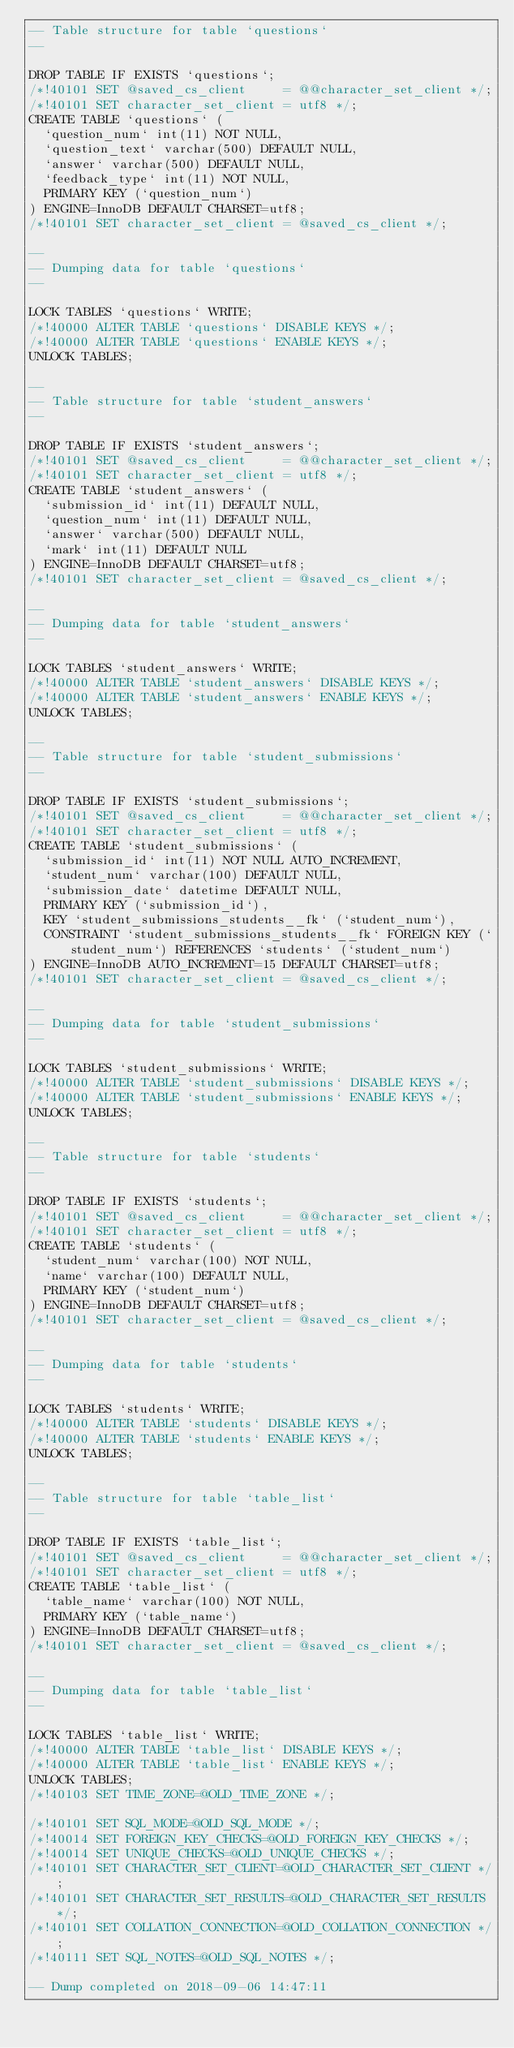Convert code to text. <code><loc_0><loc_0><loc_500><loc_500><_SQL_>-- Table structure for table `questions`
--

DROP TABLE IF EXISTS `questions`;
/*!40101 SET @saved_cs_client     = @@character_set_client */;
/*!40101 SET character_set_client = utf8 */;
CREATE TABLE `questions` (
  `question_num` int(11) NOT NULL,
  `question_text` varchar(500) DEFAULT NULL,
  `answer` varchar(500) DEFAULT NULL,
  `feedback_type` int(11) NOT NULL,
  PRIMARY KEY (`question_num`)
) ENGINE=InnoDB DEFAULT CHARSET=utf8;
/*!40101 SET character_set_client = @saved_cs_client */;

--
-- Dumping data for table `questions`
--

LOCK TABLES `questions` WRITE;
/*!40000 ALTER TABLE `questions` DISABLE KEYS */;
/*!40000 ALTER TABLE `questions` ENABLE KEYS */;
UNLOCK TABLES;

--
-- Table structure for table `student_answers`
--

DROP TABLE IF EXISTS `student_answers`;
/*!40101 SET @saved_cs_client     = @@character_set_client */;
/*!40101 SET character_set_client = utf8 */;
CREATE TABLE `student_answers` (
  `submission_id` int(11) DEFAULT NULL,
  `question_num` int(11) DEFAULT NULL,
  `answer` varchar(500) DEFAULT NULL,
  `mark` int(11) DEFAULT NULL
) ENGINE=InnoDB DEFAULT CHARSET=utf8;
/*!40101 SET character_set_client = @saved_cs_client */;

--
-- Dumping data for table `student_answers`
--

LOCK TABLES `student_answers` WRITE;
/*!40000 ALTER TABLE `student_answers` DISABLE KEYS */;
/*!40000 ALTER TABLE `student_answers` ENABLE KEYS */;
UNLOCK TABLES;

--
-- Table structure for table `student_submissions`
--

DROP TABLE IF EXISTS `student_submissions`;
/*!40101 SET @saved_cs_client     = @@character_set_client */;
/*!40101 SET character_set_client = utf8 */;
CREATE TABLE `student_submissions` (
  `submission_id` int(11) NOT NULL AUTO_INCREMENT,
  `student_num` varchar(100) DEFAULT NULL,
  `submission_date` datetime DEFAULT NULL,
  PRIMARY KEY (`submission_id`),
  KEY `student_submissions_students__fk` (`student_num`),
  CONSTRAINT `student_submissions_students__fk` FOREIGN KEY (`student_num`) REFERENCES `students` (`student_num`)
) ENGINE=InnoDB AUTO_INCREMENT=15 DEFAULT CHARSET=utf8;
/*!40101 SET character_set_client = @saved_cs_client */;

--
-- Dumping data for table `student_submissions`
--

LOCK TABLES `student_submissions` WRITE;
/*!40000 ALTER TABLE `student_submissions` DISABLE KEYS */;
/*!40000 ALTER TABLE `student_submissions` ENABLE KEYS */;
UNLOCK TABLES;

--
-- Table structure for table `students`
--

DROP TABLE IF EXISTS `students`;
/*!40101 SET @saved_cs_client     = @@character_set_client */;
/*!40101 SET character_set_client = utf8 */;
CREATE TABLE `students` (
  `student_num` varchar(100) NOT NULL,
  `name` varchar(100) DEFAULT NULL,
  PRIMARY KEY (`student_num`)
) ENGINE=InnoDB DEFAULT CHARSET=utf8;
/*!40101 SET character_set_client = @saved_cs_client */;

--
-- Dumping data for table `students`
--

LOCK TABLES `students` WRITE;
/*!40000 ALTER TABLE `students` DISABLE KEYS */;
/*!40000 ALTER TABLE `students` ENABLE KEYS */;
UNLOCK TABLES;

--
-- Table structure for table `table_list`
--

DROP TABLE IF EXISTS `table_list`;
/*!40101 SET @saved_cs_client     = @@character_set_client */;
/*!40101 SET character_set_client = utf8 */;
CREATE TABLE `table_list` (
  `table_name` varchar(100) NOT NULL,
  PRIMARY KEY (`table_name`)
) ENGINE=InnoDB DEFAULT CHARSET=utf8;
/*!40101 SET character_set_client = @saved_cs_client */;

--
-- Dumping data for table `table_list`
--

LOCK TABLES `table_list` WRITE;
/*!40000 ALTER TABLE `table_list` DISABLE KEYS */;
/*!40000 ALTER TABLE `table_list` ENABLE KEYS */;
UNLOCK TABLES;
/*!40103 SET TIME_ZONE=@OLD_TIME_ZONE */;

/*!40101 SET SQL_MODE=@OLD_SQL_MODE */;
/*!40014 SET FOREIGN_KEY_CHECKS=@OLD_FOREIGN_KEY_CHECKS */;
/*!40014 SET UNIQUE_CHECKS=@OLD_UNIQUE_CHECKS */;
/*!40101 SET CHARACTER_SET_CLIENT=@OLD_CHARACTER_SET_CLIENT */;
/*!40101 SET CHARACTER_SET_RESULTS=@OLD_CHARACTER_SET_RESULTS */;
/*!40101 SET COLLATION_CONNECTION=@OLD_COLLATION_CONNECTION */;
/*!40111 SET SQL_NOTES=@OLD_SQL_NOTES */;

-- Dump completed on 2018-09-06 14:47:11
</code> 